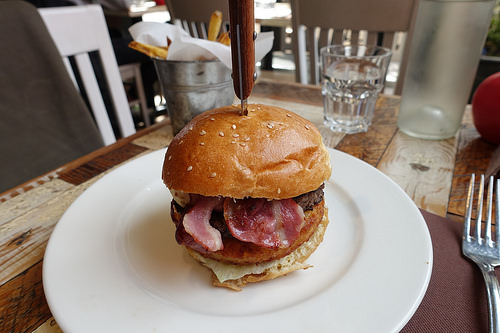<image>
Can you confirm if the knife is next to the sandwich? No. The knife is not positioned next to the sandwich. They are located in different areas of the scene. 